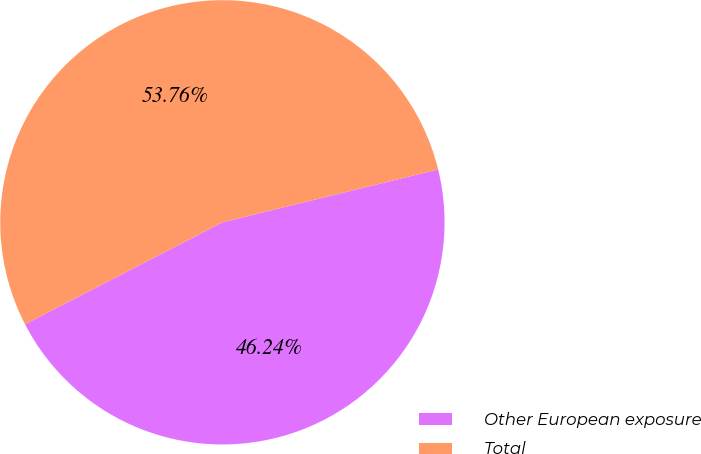Convert chart to OTSL. <chart><loc_0><loc_0><loc_500><loc_500><pie_chart><fcel>Other European exposure<fcel>Total<nl><fcel>46.24%<fcel>53.76%<nl></chart> 